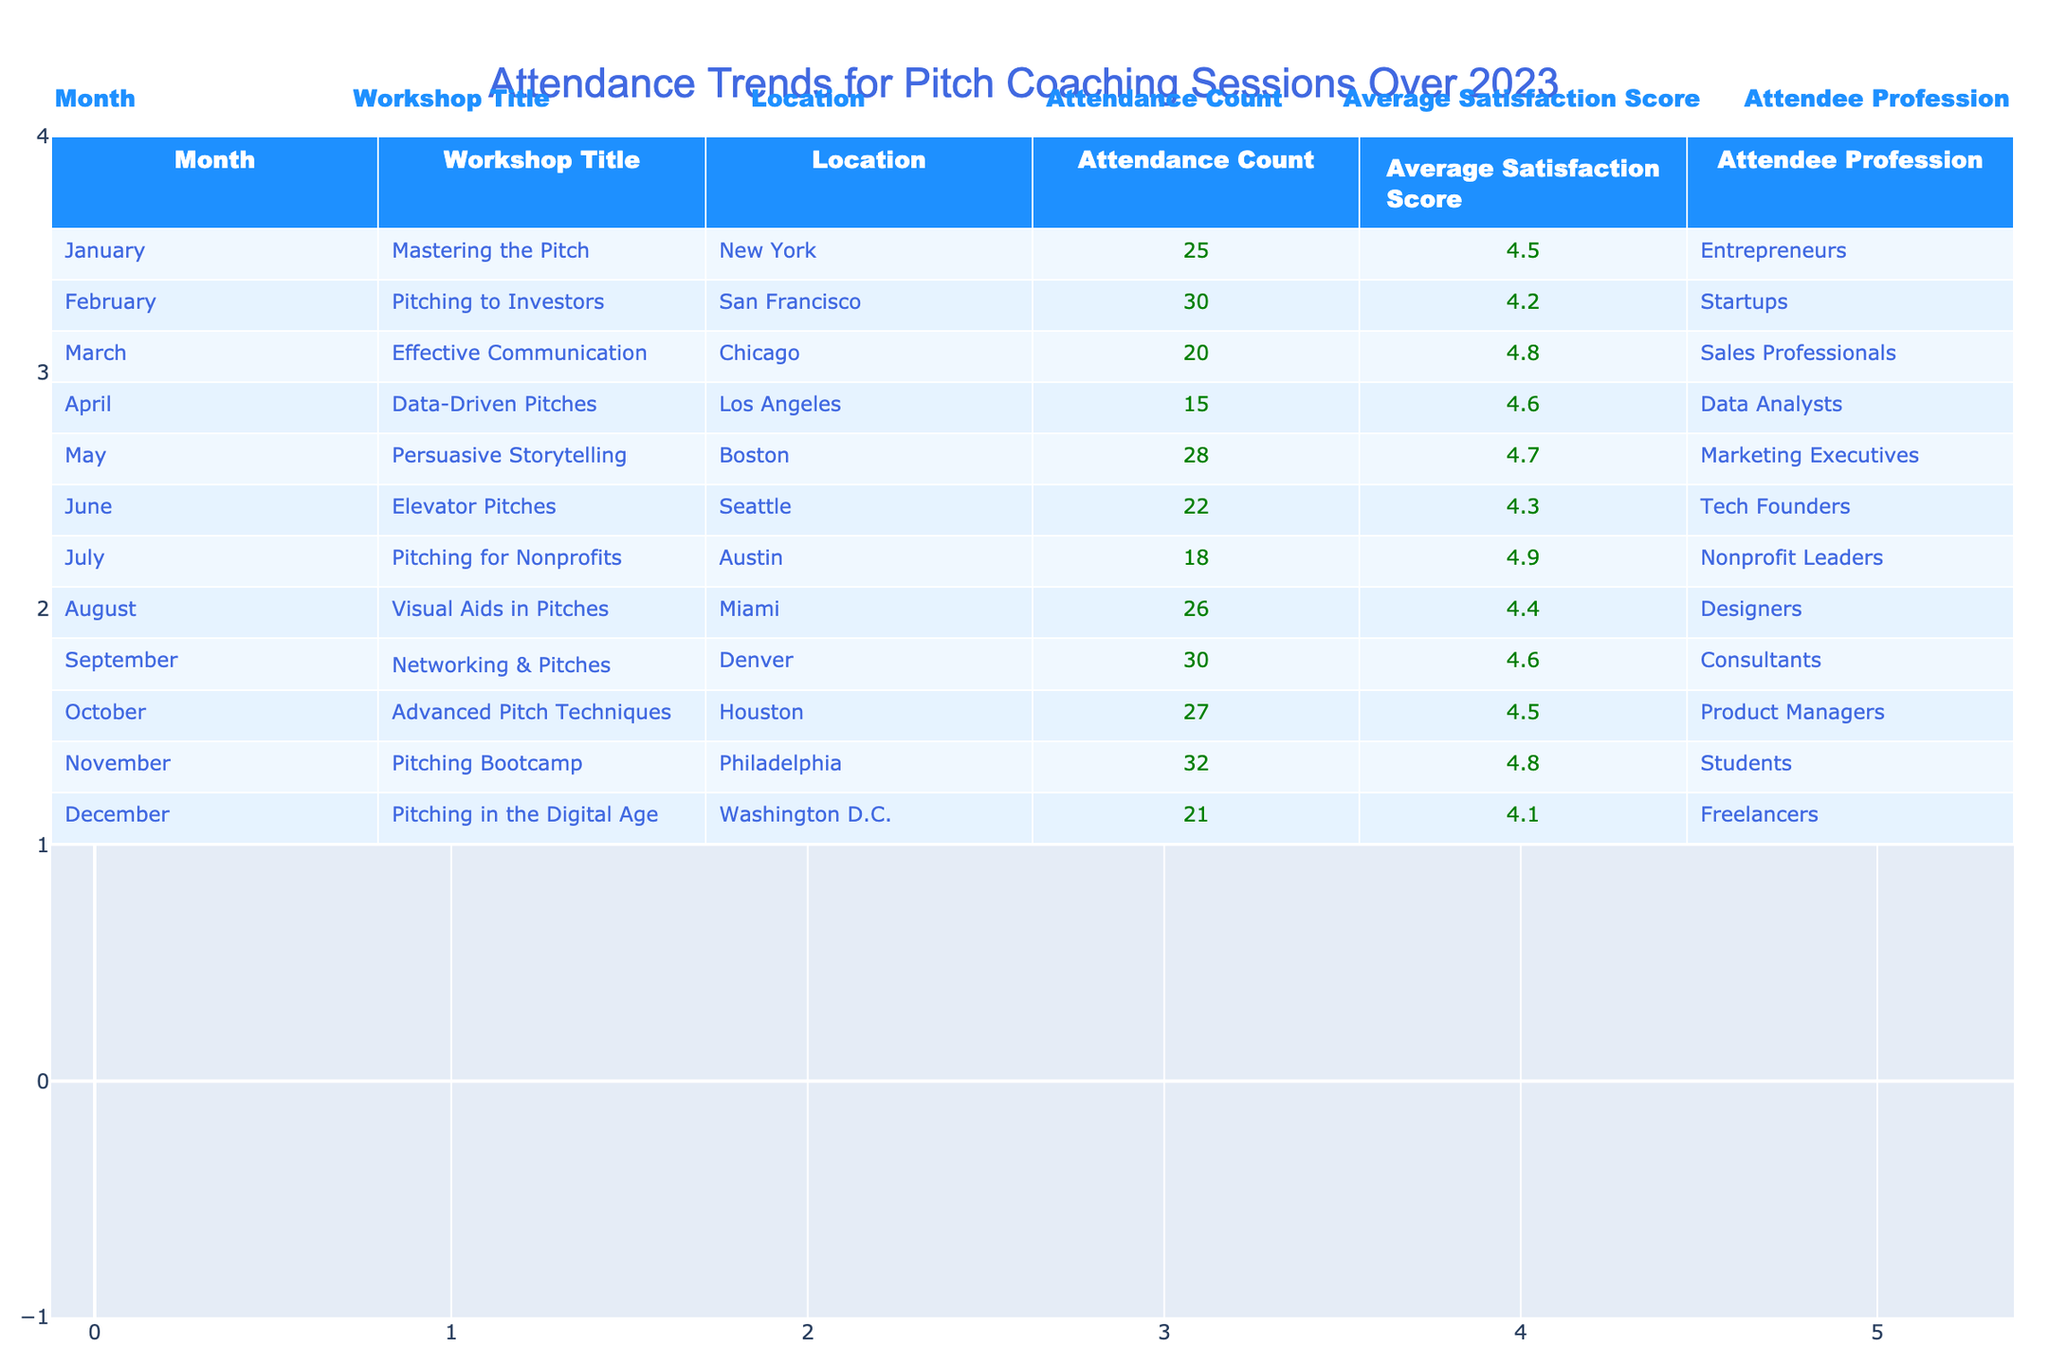What was the attendance count for the workshop "Mastering the Pitch"? The table shows that the attendance count for "Mastering the Pitch" in January is 25.
Answer: 25 Which month had the highest average satisfaction score? By examining the average satisfaction scores listed for each month, the highest score is 4.9, which occurred in July for the "Pitching for Nonprofits" workshop.
Answer: July How many workshops had an attendance count of 30 or more? The workshops with an attendance count of 30 or more are "Pitching to Investors" (30), "Networking & Pitches" (30), and "Pitching Bootcamp" (32), totaling 3 workshops.
Answer: 3 What is the average attendance count for all workshops held in 2023? The total attendance is (25 + 30 + 20 + 15 + 28 + 22 + 18 + 26 + 30 + 27 + 32 + 21) =  25.5 and there are 12 months, so the average attendance count is  25.5 / 12 ≈ 24.1.
Answer: 24.1 Did "Visual Aids in Pitches" have a higher satisfaction score than "Pitching in the Digital Age"? "Visual Aids in Pitches" has a satisfaction score of 4.4, while "Pitching in the Digital Age" has a score of 4.1. Since 4.4 is greater than 4.1, the answer is yes.
Answer: Yes How does the average attendance count for workshops in the first half of the year compare to the second half? The first half (January to June) has attendance counts of (25, 30, 20, 15, 28, 22) totaling 170, which gives an average of 170 / 6 = 28.3. The second half (July to December) has attendance counts of (18, 26, 30, 27, 32, 21) totaling 154, giving an average of 154 / 6 ≈ 25.7. Therefore, the first half had a higher average attendance than the second half.
Answer: First half is higher Which profession had the lowest attendance count? By reviewing the attendance counts grouped by profession, "Data Analysts" had the lowest attendance at 15.
Answer: Data Analysts Was there a month where all attendees were from startups? There is no workshop listed in the table that specifies all attendees as startups, so the answer is no.
Answer: No What is the average satisfaction score for workshops focused on "Pitching"? The relevant workshops are "Pitching to Investors" (4.2), "Pitching for Nonprofits" (4.9), "Pitching Bootcamp" (4.8), and "Pitching in the Digital Age" (4.1). Their average is (4.2 + 4.9 + 4.8 + 4.1) = 18.0 / 4 = 4.5.
Answer: 4.5 Which location had the lowest attendance count for the workshops? The location with the lowest attendance count is "Los Angeles," where the "Data-Driven Pitches" workshop had 15 attendees.
Answer: Los Angeles 